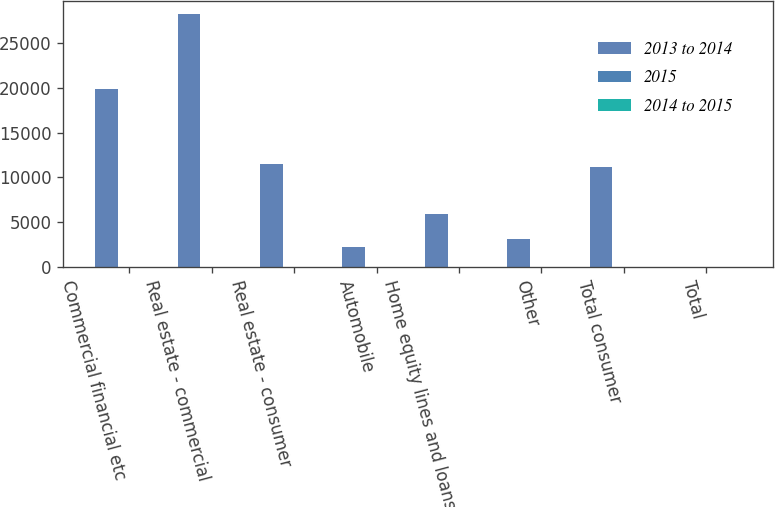Convert chart to OTSL. <chart><loc_0><loc_0><loc_500><loc_500><stacked_bar_chart><ecel><fcel>Commercial financial etc<fcel>Real estate - commercial<fcel>Real estate - consumer<fcel>Automobile<fcel>Home equity lines and loans<fcel>Other<fcel>Total consumer<fcel>Total<nl><fcel>2013 to 2014<fcel>19899<fcel>28276<fcel>11458<fcel>2216<fcel>5913<fcel>3074<fcel>11203<fcel>10<nl><fcel>2015<fcel>5<fcel>7<fcel>31<fcel>32<fcel>2<fcel>7<fcel>6<fcel>10<nl><fcel>2014 to 2015<fcel>6<fcel>1<fcel>14<fcel>23<fcel>2<fcel>5<fcel>4<fcel>1<nl></chart> 